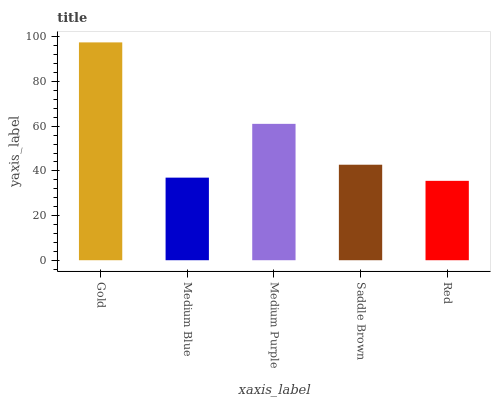Is Red the minimum?
Answer yes or no. Yes. Is Gold the maximum?
Answer yes or no. Yes. Is Medium Blue the minimum?
Answer yes or no. No. Is Medium Blue the maximum?
Answer yes or no. No. Is Gold greater than Medium Blue?
Answer yes or no. Yes. Is Medium Blue less than Gold?
Answer yes or no. Yes. Is Medium Blue greater than Gold?
Answer yes or no. No. Is Gold less than Medium Blue?
Answer yes or no. No. Is Saddle Brown the high median?
Answer yes or no. Yes. Is Saddle Brown the low median?
Answer yes or no. Yes. Is Medium Blue the high median?
Answer yes or no. No. Is Red the low median?
Answer yes or no. No. 